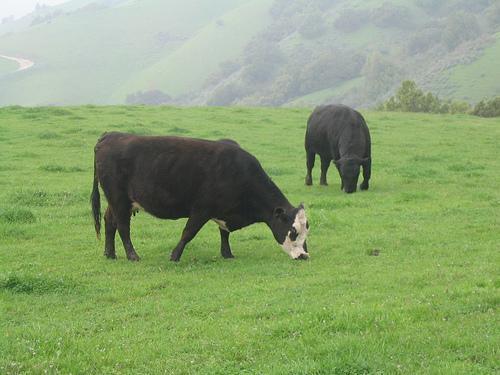How many cows are there?
Give a very brief answer. 2. 